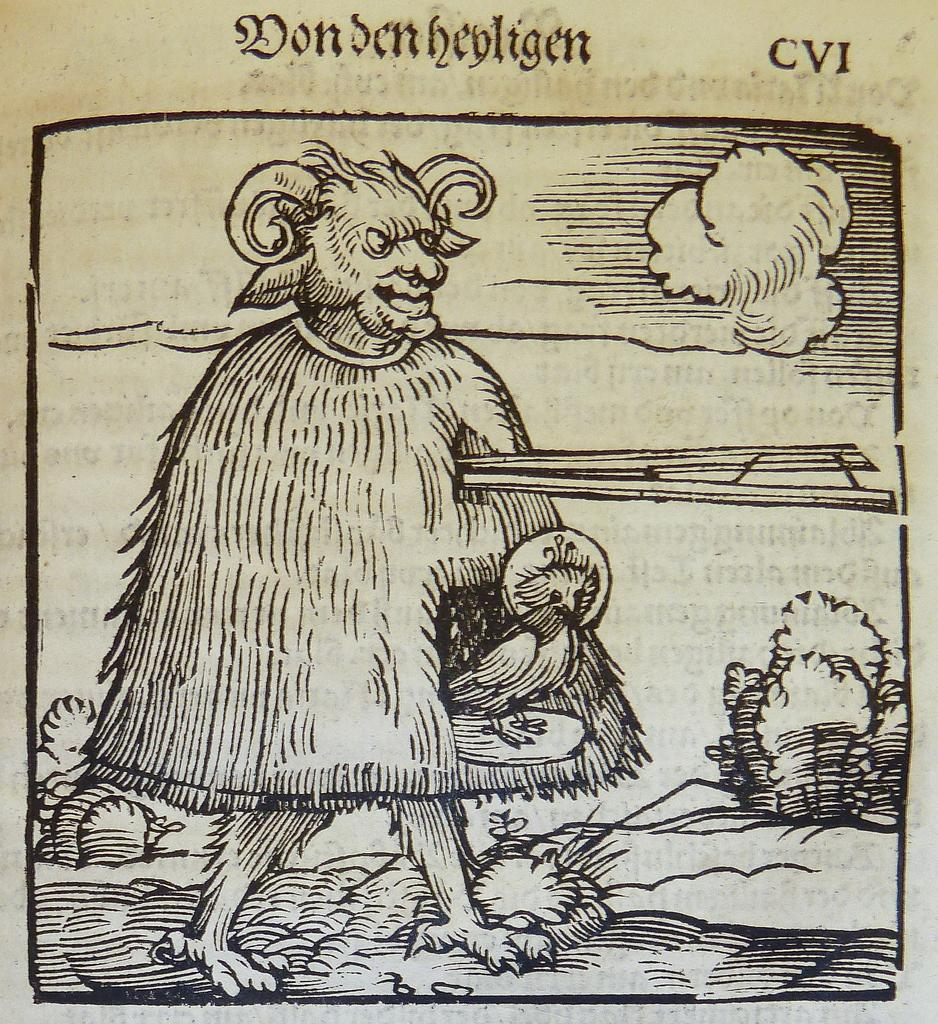What type of print is visible in the image? There is a print of an animal in the image. What type of natural environment is depicted in the image? There are trees in the image, suggesting a forest or wooded area. What is written or printed on the paper in the image? The fact mentions that there are words on the paper, so we focus on identifying the main subjects and objects in the image based on the provided facts. We then formulate questions that focus on the characteristics of these subjects and objects, ensuring that each question can be answered definitively with the information given. We avoid yes/no questions and ensure that the language is simple and clear. Absurd Question/Answer: What color of paint is being used to create the alarm in the image? There is no alarm present in the image, and therefore no paint can be associated with it. What type of liquid is being poured onto the paint in the image? There is no paint or liquid present in the image. 